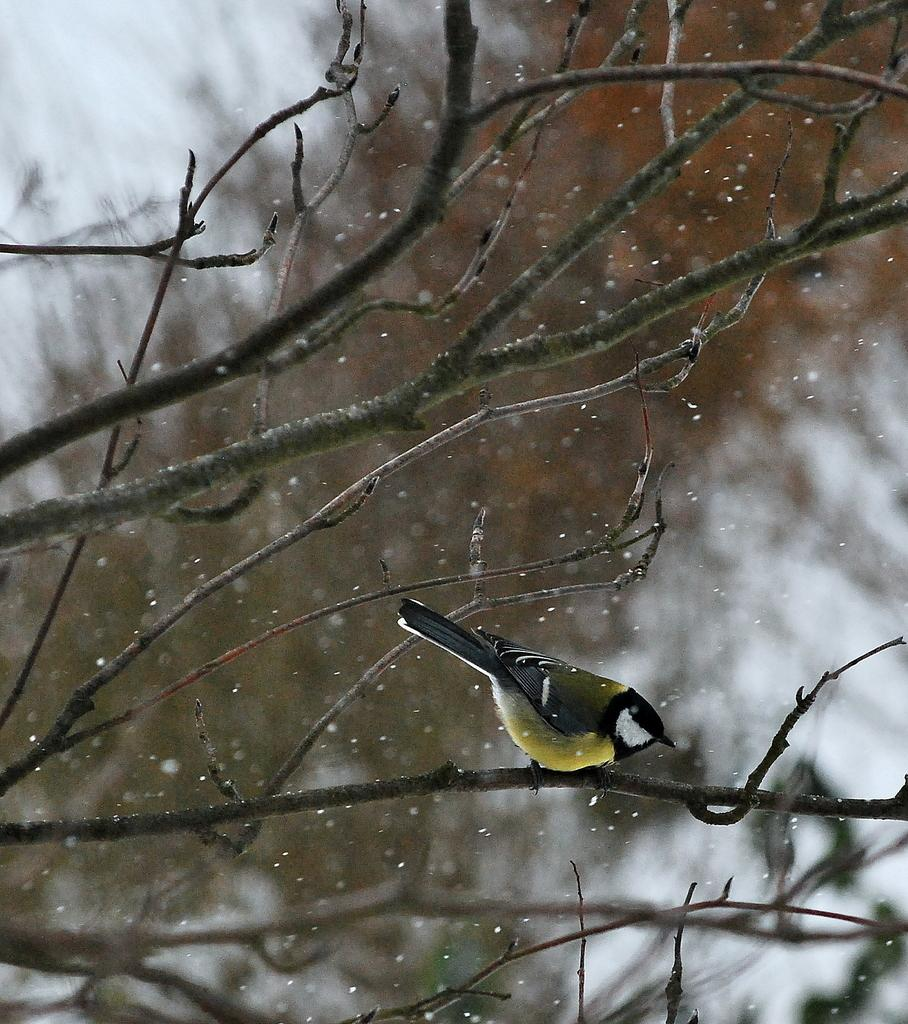What type of animal can be seen in the image? There is a bird in the image. Where is the bird located? The bird is on a branch. What is the weather like in the image? There is snow visible in the image, suggesting a cold or wintry environment. How would you describe the background of the image? The background of the image is blurry. How many boys are using the rake in the image? There are no boys or rakes present in the image. 